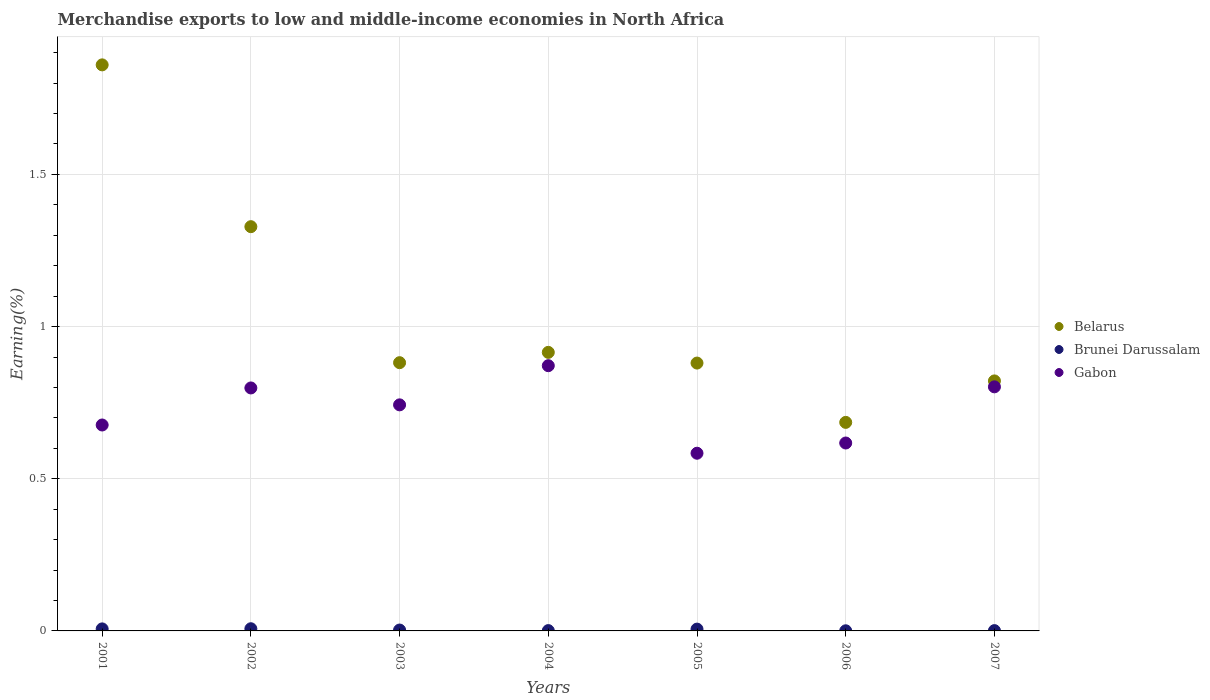How many different coloured dotlines are there?
Make the answer very short. 3. Is the number of dotlines equal to the number of legend labels?
Your answer should be very brief. Yes. What is the percentage of amount earned from merchandise exports in Gabon in 2001?
Provide a short and direct response. 0.68. Across all years, what is the maximum percentage of amount earned from merchandise exports in Brunei Darussalam?
Offer a very short reply. 0.01. Across all years, what is the minimum percentage of amount earned from merchandise exports in Gabon?
Keep it short and to the point. 0.58. In which year was the percentage of amount earned from merchandise exports in Gabon maximum?
Your answer should be compact. 2004. What is the total percentage of amount earned from merchandise exports in Belarus in the graph?
Give a very brief answer. 7.37. What is the difference between the percentage of amount earned from merchandise exports in Gabon in 2001 and that in 2006?
Give a very brief answer. 0.06. What is the difference between the percentage of amount earned from merchandise exports in Brunei Darussalam in 2002 and the percentage of amount earned from merchandise exports in Belarus in 2007?
Offer a terse response. -0.81. What is the average percentage of amount earned from merchandise exports in Belarus per year?
Offer a terse response. 1.05. In the year 2006, what is the difference between the percentage of amount earned from merchandise exports in Belarus and percentage of amount earned from merchandise exports in Brunei Darussalam?
Ensure brevity in your answer.  0.68. What is the ratio of the percentage of amount earned from merchandise exports in Belarus in 2005 to that in 2006?
Give a very brief answer. 1.28. Is the percentage of amount earned from merchandise exports in Belarus in 2001 less than that in 2007?
Give a very brief answer. No. Is the difference between the percentage of amount earned from merchandise exports in Belarus in 2001 and 2005 greater than the difference between the percentage of amount earned from merchandise exports in Brunei Darussalam in 2001 and 2005?
Provide a succinct answer. Yes. What is the difference between the highest and the second highest percentage of amount earned from merchandise exports in Brunei Darussalam?
Give a very brief answer. 0. What is the difference between the highest and the lowest percentage of amount earned from merchandise exports in Brunei Darussalam?
Provide a succinct answer. 0.01. Is the sum of the percentage of amount earned from merchandise exports in Brunei Darussalam in 2003 and 2007 greater than the maximum percentage of amount earned from merchandise exports in Belarus across all years?
Give a very brief answer. No. Is the percentage of amount earned from merchandise exports in Brunei Darussalam strictly less than the percentage of amount earned from merchandise exports in Gabon over the years?
Your response must be concise. Yes. How many dotlines are there?
Keep it short and to the point. 3. Are the values on the major ticks of Y-axis written in scientific E-notation?
Your response must be concise. No. Does the graph contain grids?
Your response must be concise. Yes. Where does the legend appear in the graph?
Ensure brevity in your answer.  Center right. What is the title of the graph?
Your answer should be very brief. Merchandise exports to low and middle-income economies in North Africa. Does "India" appear as one of the legend labels in the graph?
Your response must be concise. No. What is the label or title of the Y-axis?
Provide a succinct answer. Earning(%). What is the Earning(%) in Belarus in 2001?
Offer a terse response. 1.86. What is the Earning(%) in Brunei Darussalam in 2001?
Ensure brevity in your answer.  0.01. What is the Earning(%) in Gabon in 2001?
Keep it short and to the point. 0.68. What is the Earning(%) in Belarus in 2002?
Your response must be concise. 1.33. What is the Earning(%) of Brunei Darussalam in 2002?
Your answer should be very brief. 0.01. What is the Earning(%) in Gabon in 2002?
Ensure brevity in your answer.  0.8. What is the Earning(%) in Belarus in 2003?
Make the answer very short. 0.88. What is the Earning(%) of Brunei Darussalam in 2003?
Your answer should be very brief. 0. What is the Earning(%) in Gabon in 2003?
Offer a terse response. 0.74. What is the Earning(%) in Belarus in 2004?
Your response must be concise. 0.92. What is the Earning(%) of Brunei Darussalam in 2004?
Offer a terse response. 0. What is the Earning(%) of Gabon in 2004?
Give a very brief answer. 0.87. What is the Earning(%) in Belarus in 2005?
Ensure brevity in your answer.  0.88. What is the Earning(%) of Brunei Darussalam in 2005?
Offer a terse response. 0.01. What is the Earning(%) of Gabon in 2005?
Make the answer very short. 0.58. What is the Earning(%) in Belarus in 2006?
Make the answer very short. 0.69. What is the Earning(%) in Brunei Darussalam in 2006?
Your answer should be very brief. 0. What is the Earning(%) of Gabon in 2006?
Give a very brief answer. 0.62. What is the Earning(%) of Belarus in 2007?
Give a very brief answer. 0.82. What is the Earning(%) of Brunei Darussalam in 2007?
Offer a very short reply. 0. What is the Earning(%) of Gabon in 2007?
Your response must be concise. 0.8. Across all years, what is the maximum Earning(%) in Belarus?
Provide a short and direct response. 1.86. Across all years, what is the maximum Earning(%) of Brunei Darussalam?
Provide a short and direct response. 0.01. Across all years, what is the maximum Earning(%) in Gabon?
Your answer should be very brief. 0.87. Across all years, what is the minimum Earning(%) of Belarus?
Make the answer very short. 0.69. Across all years, what is the minimum Earning(%) of Brunei Darussalam?
Provide a succinct answer. 0. Across all years, what is the minimum Earning(%) of Gabon?
Your answer should be very brief. 0.58. What is the total Earning(%) in Belarus in the graph?
Keep it short and to the point. 7.37. What is the total Earning(%) in Brunei Darussalam in the graph?
Your answer should be compact. 0.03. What is the total Earning(%) in Gabon in the graph?
Your answer should be very brief. 5.09. What is the difference between the Earning(%) in Belarus in 2001 and that in 2002?
Make the answer very short. 0.53. What is the difference between the Earning(%) in Brunei Darussalam in 2001 and that in 2002?
Offer a very short reply. -0. What is the difference between the Earning(%) of Gabon in 2001 and that in 2002?
Make the answer very short. -0.12. What is the difference between the Earning(%) of Belarus in 2001 and that in 2003?
Keep it short and to the point. 0.98. What is the difference between the Earning(%) of Brunei Darussalam in 2001 and that in 2003?
Offer a terse response. 0. What is the difference between the Earning(%) of Gabon in 2001 and that in 2003?
Provide a short and direct response. -0.07. What is the difference between the Earning(%) of Belarus in 2001 and that in 2004?
Provide a short and direct response. 0.94. What is the difference between the Earning(%) of Brunei Darussalam in 2001 and that in 2004?
Your response must be concise. 0.01. What is the difference between the Earning(%) in Gabon in 2001 and that in 2004?
Provide a short and direct response. -0.19. What is the difference between the Earning(%) in Belarus in 2001 and that in 2005?
Provide a succinct answer. 0.98. What is the difference between the Earning(%) in Brunei Darussalam in 2001 and that in 2005?
Give a very brief answer. 0. What is the difference between the Earning(%) of Gabon in 2001 and that in 2005?
Your answer should be very brief. 0.09. What is the difference between the Earning(%) of Belarus in 2001 and that in 2006?
Give a very brief answer. 1.17. What is the difference between the Earning(%) in Brunei Darussalam in 2001 and that in 2006?
Offer a terse response. 0.01. What is the difference between the Earning(%) of Gabon in 2001 and that in 2006?
Offer a terse response. 0.06. What is the difference between the Earning(%) of Belarus in 2001 and that in 2007?
Make the answer very short. 1.04. What is the difference between the Earning(%) of Brunei Darussalam in 2001 and that in 2007?
Make the answer very short. 0.01. What is the difference between the Earning(%) of Gabon in 2001 and that in 2007?
Your response must be concise. -0.13. What is the difference between the Earning(%) in Belarus in 2002 and that in 2003?
Keep it short and to the point. 0.45. What is the difference between the Earning(%) of Brunei Darussalam in 2002 and that in 2003?
Your response must be concise. 0. What is the difference between the Earning(%) of Gabon in 2002 and that in 2003?
Offer a very short reply. 0.06. What is the difference between the Earning(%) in Belarus in 2002 and that in 2004?
Provide a short and direct response. 0.41. What is the difference between the Earning(%) in Brunei Darussalam in 2002 and that in 2004?
Provide a short and direct response. 0.01. What is the difference between the Earning(%) of Gabon in 2002 and that in 2004?
Keep it short and to the point. -0.07. What is the difference between the Earning(%) of Belarus in 2002 and that in 2005?
Offer a very short reply. 0.45. What is the difference between the Earning(%) of Brunei Darussalam in 2002 and that in 2005?
Your response must be concise. 0. What is the difference between the Earning(%) in Gabon in 2002 and that in 2005?
Make the answer very short. 0.21. What is the difference between the Earning(%) in Belarus in 2002 and that in 2006?
Your answer should be very brief. 0.64. What is the difference between the Earning(%) in Brunei Darussalam in 2002 and that in 2006?
Provide a short and direct response. 0.01. What is the difference between the Earning(%) in Gabon in 2002 and that in 2006?
Provide a succinct answer. 0.18. What is the difference between the Earning(%) in Belarus in 2002 and that in 2007?
Your answer should be very brief. 0.51. What is the difference between the Earning(%) in Brunei Darussalam in 2002 and that in 2007?
Make the answer very short. 0.01. What is the difference between the Earning(%) of Gabon in 2002 and that in 2007?
Ensure brevity in your answer.  -0. What is the difference between the Earning(%) of Belarus in 2003 and that in 2004?
Offer a terse response. -0.03. What is the difference between the Earning(%) of Brunei Darussalam in 2003 and that in 2004?
Ensure brevity in your answer.  0. What is the difference between the Earning(%) in Gabon in 2003 and that in 2004?
Give a very brief answer. -0.13. What is the difference between the Earning(%) in Belarus in 2003 and that in 2005?
Your response must be concise. 0. What is the difference between the Earning(%) in Brunei Darussalam in 2003 and that in 2005?
Your answer should be very brief. -0. What is the difference between the Earning(%) of Gabon in 2003 and that in 2005?
Keep it short and to the point. 0.16. What is the difference between the Earning(%) in Belarus in 2003 and that in 2006?
Keep it short and to the point. 0.2. What is the difference between the Earning(%) in Brunei Darussalam in 2003 and that in 2006?
Keep it short and to the point. 0. What is the difference between the Earning(%) in Gabon in 2003 and that in 2006?
Offer a terse response. 0.13. What is the difference between the Earning(%) of Belarus in 2003 and that in 2007?
Your answer should be compact. 0.06. What is the difference between the Earning(%) of Brunei Darussalam in 2003 and that in 2007?
Make the answer very short. 0. What is the difference between the Earning(%) of Gabon in 2003 and that in 2007?
Keep it short and to the point. -0.06. What is the difference between the Earning(%) of Belarus in 2004 and that in 2005?
Offer a terse response. 0.04. What is the difference between the Earning(%) in Brunei Darussalam in 2004 and that in 2005?
Your answer should be compact. -0. What is the difference between the Earning(%) in Gabon in 2004 and that in 2005?
Ensure brevity in your answer.  0.29. What is the difference between the Earning(%) of Belarus in 2004 and that in 2006?
Provide a short and direct response. 0.23. What is the difference between the Earning(%) in Brunei Darussalam in 2004 and that in 2006?
Provide a succinct answer. 0. What is the difference between the Earning(%) in Gabon in 2004 and that in 2006?
Provide a short and direct response. 0.25. What is the difference between the Earning(%) of Belarus in 2004 and that in 2007?
Your response must be concise. 0.09. What is the difference between the Earning(%) of Brunei Darussalam in 2004 and that in 2007?
Your answer should be compact. 0. What is the difference between the Earning(%) in Gabon in 2004 and that in 2007?
Offer a terse response. 0.07. What is the difference between the Earning(%) of Belarus in 2005 and that in 2006?
Your answer should be compact. 0.19. What is the difference between the Earning(%) of Brunei Darussalam in 2005 and that in 2006?
Your answer should be very brief. 0.01. What is the difference between the Earning(%) in Gabon in 2005 and that in 2006?
Make the answer very short. -0.03. What is the difference between the Earning(%) in Belarus in 2005 and that in 2007?
Your answer should be very brief. 0.06. What is the difference between the Earning(%) of Brunei Darussalam in 2005 and that in 2007?
Your response must be concise. 0. What is the difference between the Earning(%) of Gabon in 2005 and that in 2007?
Offer a very short reply. -0.22. What is the difference between the Earning(%) of Belarus in 2006 and that in 2007?
Ensure brevity in your answer.  -0.14. What is the difference between the Earning(%) of Brunei Darussalam in 2006 and that in 2007?
Your response must be concise. -0. What is the difference between the Earning(%) of Gabon in 2006 and that in 2007?
Provide a succinct answer. -0.18. What is the difference between the Earning(%) of Belarus in 2001 and the Earning(%) of Brunei Darussalam in 2002?
Your answer should be compact. 1.85. What is the difference between the Earning(%) in Belarus in 2001 and the Earning(%) in Gabon in 2002?
Offer a terse response. 1.06. What is the difference between the Earning(%) in Brunei Darussalam in 2001 and the Earning(%) in Gabon in 2002?
Give a very brief answer. -0.79. What is the difference between the Earning(%) in Belarus in 2001 and the Earning(%) in Brunei Darussalam in 2003?
Offer a terse response. 1.86. What is the difference between the Earning(%) of Belarus in 2001 and the Earning(%) of Gabon in 2003?
Offer a terse response. 1.12. What is the difference between the Earning(%) of Brunei Darussalam in 2001 and the Earning(%) of Gabon in 2003?
Make the answer very short. -0.74. What is the difference between the Earning(%) of Belarus in 2001 and the Earning(%) of Brunei Darussalam in 2004?
Provide a short and direct response. 1.86. What is the difference between the Earning(%) of Belarus in 2001 and the Earning(%) of Gabon in 2004?
Keep it short and to the point. 0.99. What is the difference between the Earning(%) of Brunei Darussalam in 2001 and the Earning(%) of Gabon in 2004?
Give a very brief answer. -0.86. What is the difference between the Earning(%) in Belarus in 2001 and the Earning(%) in Brunei Darussalam in 2005?
Make the answer very short. 1.85. What is the difference between the Earning(%) of Belarus in 2001 and the Earning(%) of Gabon in 2005?
Your answer should be compact. 1.28. What is the difference between the Earning(%) in Brunei Darussalam in 2001 and the Earning(%) in Gabon in 2005?
Offer a very short reply. -0.58. What is the difference between the Earning(%) in Belarus in 2001 and the Earning(%) in Brunei Darussalam in 2006?
Give a very brief answer. 1.86. What is the difference between the Earning(%) of Belarus in 2001 and the Earning(%) of Gabon in 2006?
Make the answer very short. 1.24. What is the difference between the Earning(%) of Brunei Darussalam in 2001 and the Earning(%) of Gabon in 2006?
Your response must be concise. -0.61. What is the difference between the Earning(%) in Belarus in 2001 and the Earning(%) in Brunei Darussalam in 2007?
Ensure brevity in your answer.  1.86. What is the difference between the Earning(%) in Belarus in 2001 and the Earning(%) in Gabon in 2007?
Your answer should be compact. 1.06. What is the difference between the Earning(%) in Brunei Darussalam in 2001 and the Earning(%) in Gabon in 2007?
Your answer should be very brief. -0.8. What is the difference between the Earning(%) in Belarus in 2002 and the Earning(%) in Brunei Darussalam in 2003?
Provide a succinct answer. 1.33. What is the difference between the Earning(%) of Belarus in 2002 and the Earning(%) of Gabon in 2003?
Give a very brief answer. 0.59. What is the difference between the Earning(%) in Brunei Darussalam in 2002 and the Earning(%) in Gabon in 2003?
Offer a terse response. -0.74. What is the difference between the Earning(%) in Belarus in 2002 and the Earning(%) in Brunei Darussalam in 2004?
Make the answer very short. 1.33. What is the difference between the Earning(%) in Belarus in 2002 and the Earning(%) in Gabon in 2004?
Ensure brevity in your answer.  0.46. What is the difference between the Earning(%) of Brunei Darussalam in 2002 and the Earning(%) of Gabon in 2004?
Your response must be concise. -0.86. What is the difference between the Earning(%) of Belarus in 2002 and the Earning(%) of Brunei Darussalam in 2005?
Your answer should be very brief. 1.32. What is the difference between the Earning(%) in Belarus in 2002 and the Earning(%) in Gabon in 2005?
Offer a very short reply. 0.74. What is the difference between the Earning(%) in Brunei Darussalam in 2002 and the Earning(%) in Gabon in 2005?
Your response must be concise. -0.58. What is the difference between the Earning(%) in Belarus in 2002 and the Earning(%) in Brunei Darussalam in 2006?
Your response must be concise. 1.33. What is the difference between the Earning(%) of Belarus in 2002 and the Earning(%) of Gabon in 2006?
Your answer should be very brief. 0.71. What is the difference between the Earning(%) in Brunei Darussalam in 2002 and the Earning(%) in Gabon in 2006?
Your answer should be compact. -0.61. What is the difference between the Earning(%) of Belarus in 2002 and the Earning(%) of Brunei Darussalam in 2007?
Your answer should be compact. 1.33. What is the difference between the Earning(%) in Belarus in 2002 and the Earning(%) in Gabon in 2007?
Keep it short and to the point. 0.53. What is the difference between the Earning(%) of Brunei Darussalam in 2002 and the Earning(%) of Gabon in 2007?
Your answer should be very brief. -0.79. What is the difference between the Earning(%) in Belarus in 2003 and the Earning(%) in Brunei Darussalam in 2004?
Provide a succinct answer. 0.88. What is the difference between the Earning(%) of Belarus in 2003 and the Earning(%) of Gabon in 2004?
Your response must be concise. 0.01. What is the difference between the Earning(%) in Brunei Darussalam in 2003 and the Earning(%) in Gabon in 2004?
Offer a terse response. -0.87. What is the difference between the Earning(%) of Belarus in 2003 and the Earning(%) of Brunei Darussalam in 2005?
Your answer should be compact. 0.88. What is the difference between the Earning(%) of Belarus in 2003 and the Earning(%) of Gabon in 2005?
Your answer should be compact. 0.3. What is the difference between the Earning(%) in Brunei Darussalam in 2003 and the Earning(%) in Gabon in 2005?
Provide a short and direct response. -0.58. What is the difference between the Earning(%) of Belarus in 2003 and the Earning(%) of Brunei Darussalam in 2006?
Give a very brief answer. 0.88. What is the difference between the Earning(%) in Belarus in 2003 and the Earning(%) in Gabon in 2006?
Offer a very short reply. 0.26. What is the difference between the Earning(%) in Brunei Darussalam in 2003 and the Earning(%) in Gabon in 2006?
Offer a terse response. -0.61. What is the difference between the Earning(%) of Belarus in 2003 and the Earning(%) of Brunei Darussalam in 2007?
Keep it short and to the point. 0.88. What is the difference between the Earning(%) in Belarus in 2003 and the Earning(%) in Gabon in 2007?
Your answer should be compact. 0.08. What is the difference between the Earning(%) in Brunei Darussalam in 2003 and the Earning(%) in Gabon in 2007?
Offer a terse response. -0.8. What is the difference between the Earning(%) of Belarus in 2004 and the Earning(%) of Brunei Darussalam in 2005?
Provide a succinct answer. 0.91. What is the difference between the Earning(%) of Belarus in 2004 and the Earning(%) of Gabon in 2005?
Your answer should be very brief. 0.33. What is the difference between the Earning(%) in Brunei Darussalam in 2004 and the Earning(%) in Gabon in 2005?
Offer a very short reply. -0.58. What is the difference between the Earning(%) in Belarus in 2004 and the Earning(%) in Brunei Darussalam in 2006?
Make the answer very short. 0.91. What is the difference between the Earning(%) in Belarus in 2004 and the Earning(%) in Gabon in 2006?
Your answer should be very brief. 0.3. What is the difference between the Earning(%) in Brunei Darussalam in 2004 and the Earning(%) in Gabon in 2006?
Offer a very short reply. -0.62. What is the difference between the Earning(%) of Belarus in 2004 and the Earning(%) of Brunei Darussalam in 2007?
Give a very brief answer. 0.91. What is the difference between the Earning(%) of Belarus in 2004 and the Earning(%) of Gabon in 2007?
Make the answer very short. 0.11. What is the difference between the Earning(%) of Brunei Darussalam in 2004 and the Earning(%) of Gabon in 2007?
Offer a terse response. -0.8. What is the difference between the Earning(%) in Belarus in 2005 and the Earning(%) in Brunei Darussalam in 2006?
Keep it short and to the point. 0.88. What is the difference between the Earning(%) of Belarus in 2005 and the Earning(%) of Gabon in 2006?
Provide a short and direct response. 0.26. What is the difference between the Earning(%) in Brunei Darussalam in 2005 and the Earning(%) in Gabon in 2006?
Ensure brevity in your answer.  -0.61. What is the difference between the Earning(%) of Belarus in 2005 and the Earning(%) of Brunei Darussalam in 2007?
Your answer should be compact. 0.88. What is the difference between the Earning(%) of Belarus in 2005 and the Earning(%) of Gabon in 2007?
Provide a succinct answer. 0.08. What is the difference between the Earning(%) of Brunei Darussalam in 2005 and the Earning(%) of Gabon in 2007?
Your response must be concise. -0.8. What is the difference between the Earning(%) of Belarus in 2006 and the Earning(%) of Brunei Darussalam in 2007?
Provide a short and direct response. 0.68. What is the difference between the Earning(%) in Belarus in 2006 and the Earning(%) in Gabon in 2007?
Keep it short and to the point. -0.12. What is the difference between the Earning(%) in Brunei Darussalam in 2006 and the Earning(%) in Gabon in 2007?
Make the answer very short. -0.8. What is the average Earning(%) of Belarus per year?
Give a very brief answer. 1.05. What is the average Earning(%) of Brunei Darussalam per year?
Make the answer very short. 0. What is the average Earning(%) of Gabon per year?
Provide a succinct answer. 0.73. In the year 2001, what is the difference between the Earning(%) in Belarus and Earning(%) in Brunei Darussalam?
Provide a short and direct response. 1.85. In the year 2001, what is the difference between the Earning(%) of Belarus and Earning(%) of Gabon?
Make the answer very short. 1.18. In the year 2001, what is the difference between the Earning(%) in Brunei Darussalam and Earning(%) in Gabon?
Ensure brevity in your answer.  -0.67. In the year 2002, what is the difference between the Earning(%) in Belarus and Earning(%) in Brunei Darussalam?
Make the answer very short. 1.32. In the year 2002, what is the difference between the Earning(%) of Belarus and Earning(%) of Gabon?
Your response must be concise. 0.53. In the year 2002, what is the difference between the Earning(%) in Brunei Darussalam and Earning(%) in Gabon?
Provide a short and direct response. -0.79. In the year 2003, what is the difference between the Earning(%) in Belarus and Earning(%) in Brunei Darussalam?
Keep it short and to the point. 0.88. In the year 2003, what is the difference between the Earning(%) of Belarus and Earning(%) of Gabon?
Keep it short and to the point. 0.14. In the year 2003, what is the difference between the Earning(%) of Brunei Darussalam and Earning(%) of Gabon?
Offer a very short reply. -0.74. In the year 2004, what is the difference between the Earning(%) of Belarus and Earning(%) of Brunei Darussalam?
Your answer should be very brief. 0.91. In the year 2004, what is the difference between the Earning(%) of Belarus and Earning(%) of Gabon?
Offer a terse response. 0.04. In the year 2004, what is the difference between the Earning(%) of Brunei Darussalam and Earning(%) of Gabon?
Ensure brevity in your answer.  -0.87. In the year 2005, what is the difference between the Earning(%) in Belarus and Earning(%) in Brunei Darussalam?
Offer a terse response. 0.87. In the year 2005, what is the difference between the Earning(%) in Belarus and Earning(%) in Gabon?
Your answer should be compact. 0.3. In the year 2005, what is the difference between the Earning(%) of Brunei Darussalam and Earning(%) of Gabon?
Your response must be concise. -0.58. In the year 2006, what is the difference between the Earning(%) of Belarus and Earning(%) of Brunei Darussalam?
Give a very brief answer. 0.68. In the year 2006, what is the difference between the Earning(%) of Belarus and Earning(%) of Gabon?
Offer a terse response. 0.07. In the year 2006, what is the difference between the Earning(%) of Brunei Darussalam and Earning(%) of Gabon?
Your response must be concise. -0.62. In the year 2007, what is the difference between the Earning(%) of Belarus and Earning(%) of Brunei Darussalam?
Provide a succinct answer. 0.82. In the year 2007, what is the difference between the Earning(%) in Belarus and Earning(%) in Gabon?
Offer a very short reply. 0.02. In the year 2007, what is the difference between the Earning(%) in Brunei Darussalam and Earning(%) in Gabon?
Your response must be concise. -0.8. What is the ratio of the Earning(%) in Belarus in 2001 to that in 2002?
Ensure brevity in your answer.  1.4. What is the ratio of the Earning(%) in Brunei Darussalam in 2001 to that in 2002?
Your answer should be compact. 0.93. What is the ratio of the Earning(%) in Gabon in 2001 to that in 2002?
Your answer should be very brief. 0.85. What is the ratio of the Earning(%) in Belarus in 2001 to that in 2003?
Your response must be concise. 2.11. What is the ratio of the Earning(%) in Brunei Darussalam in 2001 to that in 2003?
Your response must be concise. 2.29. What is the ratio of the Earning(%) of Gabon in 2001 to that in 2003?
Your answer should be compact. 0.91. What is the ratio of the Earning(%) in Belarus in 2001 to that in 2004?
Your answer should be compact. 2.03. What is the ratio of the Earning(%) of Brunei Darussalam in 2001 to that in 2004?
Offer a very short reply. 6.43. What is the ratio of the Earning(%) in Gabon in 2001 to that in 2004?
Ensure brevity in your answer.  0.78. What is the ratio of the Earning(%) in Belarus in 2001 to that in 2005?
Offer a terse response. 2.11. What is the ratio of the Earning(%) in Brunei Darussalam in 2001 to that in 2005?
Give a very brief answer. 1.12. What is the ratio of the Earning(%) in Gabon in 2001 to that in 2005?
Offer a very short reply. 1.16. What is the ratio of the Earning(%) of Belarus in 2001 to that in 2006?
Provide a short and direct response. 2.71. What is the ratio of the Earning(%) of Brunei Darussalam in 2001 to that in 2006?
Your answer should be compact. 14.54. What is the ratio of the Earning(%) of Gabon in 2001 to that in 2006?
Your response must be concise. 1.1. What is the ratio of the Earning(%) of Belarus in 2001 to that in 2007?
Your answer should be compact. 2.26. What is the ratio of the Earning(%) of Brunei Darussalam in 2001 to that in 2007?
Offer a terse response. 6.63. What is the ratio of the Earning(%) in Gabon in 2001 to that in 2007?
Make the answer very short. 0.84. What is the ratio of the Earning(%) in Belarus in 2002 to that in 2003?
Your response must be concise. 1.51. What is the ratio of the Earning(%) in Brunei Darussalam in 2002 to that in 2003?
Keep it short and to the point. 2.46. What is the ratio of the Earning(%) of Gabon in 2002 to that in 2003?
Provide a succinct answer. 1.07. What is the ratio of the Earning(%) of Belarus in 2002 to that in 2004?
Make the answer very short. 1.45. What is the ratio of the Earning(%) in Brunei Darussalam in 2002 to that in 2004?
Your answer should be very brief. 6.9. What is the ratio of the Earning(%) in Gabon in 2002 to that in 2004?
Make the answer very short. 0.92. What is the ratio of the Earning(%) of Belarus in 2002 to that in 2005?
Give a very brief answer. 1.51. What is the ratio of the Earning(%) of Brunei Darussalam in 2002 to that in 2005?
Make the answer very short. 1.2. What is the ratio of the Earning(%) of Gabon in 2002 to that in 2005?
Your answer should be very brief. 1.37. What is the ratio of the Earning(%) of Belarus in 2002 to that in 2006?
Keep it short and to the point. 1.94. What is the ratio of the Earning(%) in Brunei Darussalam in 2002 to that in 2006?
Your answer should be very brief. 15.61. What is the ratio of the Earning(%) in Gabon in 2002 to that in 2006?
Offer a very short reply. 1.29. What is the ratio of the Earning(%) in Belarus in 2002 to that in 2007?
Your answer should be compact. 1.62. What is the ratio of the Earning(%) of Brunei Darussalam in 2002 to that in 2007?
Your answer should be compact. 7.12. What is the ratio of the Earning(%) of Gabon in 2002 to that in 2007?
Provide a short and direct response. 1. What is the ratio of the Earning(%) in Brunei Darussalam in 2003 to that in 2004?
Keep it short and to the point. 2.81. What is the ratio of the Earning(%) in Gabon in 2003 to that in 2004?
Ensure brevity in your answer.  0.85. What is the ratio of the Earning(%) of Brunei Darussalam in 2003 to that in 2005?
Provide a short and direct response. 0.49. What is the ratio of the Earning(%) in Gabon in 2003 to that in 2005?
Give a very brief answer. 1.27. What is the ratio of the Earning(%) of Belarus in 2003 to that in 2006?
Provide a succinct answer. 1.29. What is the ratio of the Earning(%) in Brunei Darussalam in 2003 to that in 2006?
Offer a terse response. 6.35. What is the ratio of the Earning(%) in Gabon in 2003 to that in 2006?
Provide a succinct answer. 1.2. What is the ratio of the Earning(%) in Belarus in 2003 to that in 2007?
Provide a succinct answer. 1.07. What is the ratio of the Earning(%) in Brunei Darussalam in 2003 to that in 2007?
Ensure brevity in your answer.  2.9. What is the ratio of the Earning(%) of Gabon in 2003 to that in 2007?
Ensure brevity in your answer.  0.93. What is the ratio of the Earning(%) in Brunei Darussalam in 2004 to that in 2005?
Offer a very short reply. 0.17. What is the ratio of the Earning(%) in Gabon in 2004 to that in 2005?
Provide a short and direct response. 1.49. What is the ratio of the Earning(%) of Belarus in 2004 to that in 2006?
Offer a very short reply. 1.34. What is the ratio of the Earning(%) of Brunei Darussalam in 2004 to that in 2006?
Ensure brevity in your answer.  2.26. What is the ratio of the Earning(%) of Gabon in 2004 to that in 2006?
Provide a succinct answer. 1.41. What is the ratio of the Earning(%) in Belarus in 2004 to that in 2007?
Your answer should be compact. 1.11. What is the ratio of the Earning(%) in Brunei Darussalam in 2004 to that in 2007?
Provide a short and direct response. 1.03. What is the ratio of the Earning(%) in Gabon in 2004 to that in 2007?
Offer a very short reply. 1.09. What is the ratio of the Earning(%) of Belarus in 2005 to that in 2006?
Make the answer very short. 1.28. What is the ratio of the Earning(%) in Brunei Darussalam in 2005 to that in 2006?
Your response must be concise. 12.96. What is the ratio of the Earning(%) of Gabon in 2005 to that in 2006?
Offer a terse response. 0.95. What is the ratio of the Earning(%) of Belarus in 2005 to that in 2007?
Provide a short and direct response. 1.07. What is the ratio of the Earning(%) of Brunei Darussalam in 2005 to that in 2007?
Provide a succinct answer. 5.91. What is the ratio of the Earning(%) in Gabon in 2005 to that in 2007?
Keep it short and to the point. 0.73. What is the ratio of the Earning(%) of Belarus in 2006 to that in 2007?
Keep it short and to the point. 0.83. What is the ratio of the Earning(%) in Brunei Darussalam in 2006 to that in 2007?
Offer a terse response. 0.46. What is the ratio of the Earning(%) of Gabon in 2006 to that in 2007?
Provide a succinct answer. 0.77. What is the difference between the highest and the second highest Earning(%) in Belarus?
Give a very brief answer. 0.53. What is the difference between the highest and the second highest Earning(%) of Gabon?
Make the answer very short. 0.07. What is the difference between the highest and the lowest Earning(%) in Belarus?
Ensure brevity in your answer.  1.17. What is the difference between the highest and the lowest Earning(%) of Brunei Darussalam?
Provide a short and direct response. 0.01. What is the difference between the highest and the lowest Earning(%) of Gabon?
Your answer should be very brief. 0.29. 